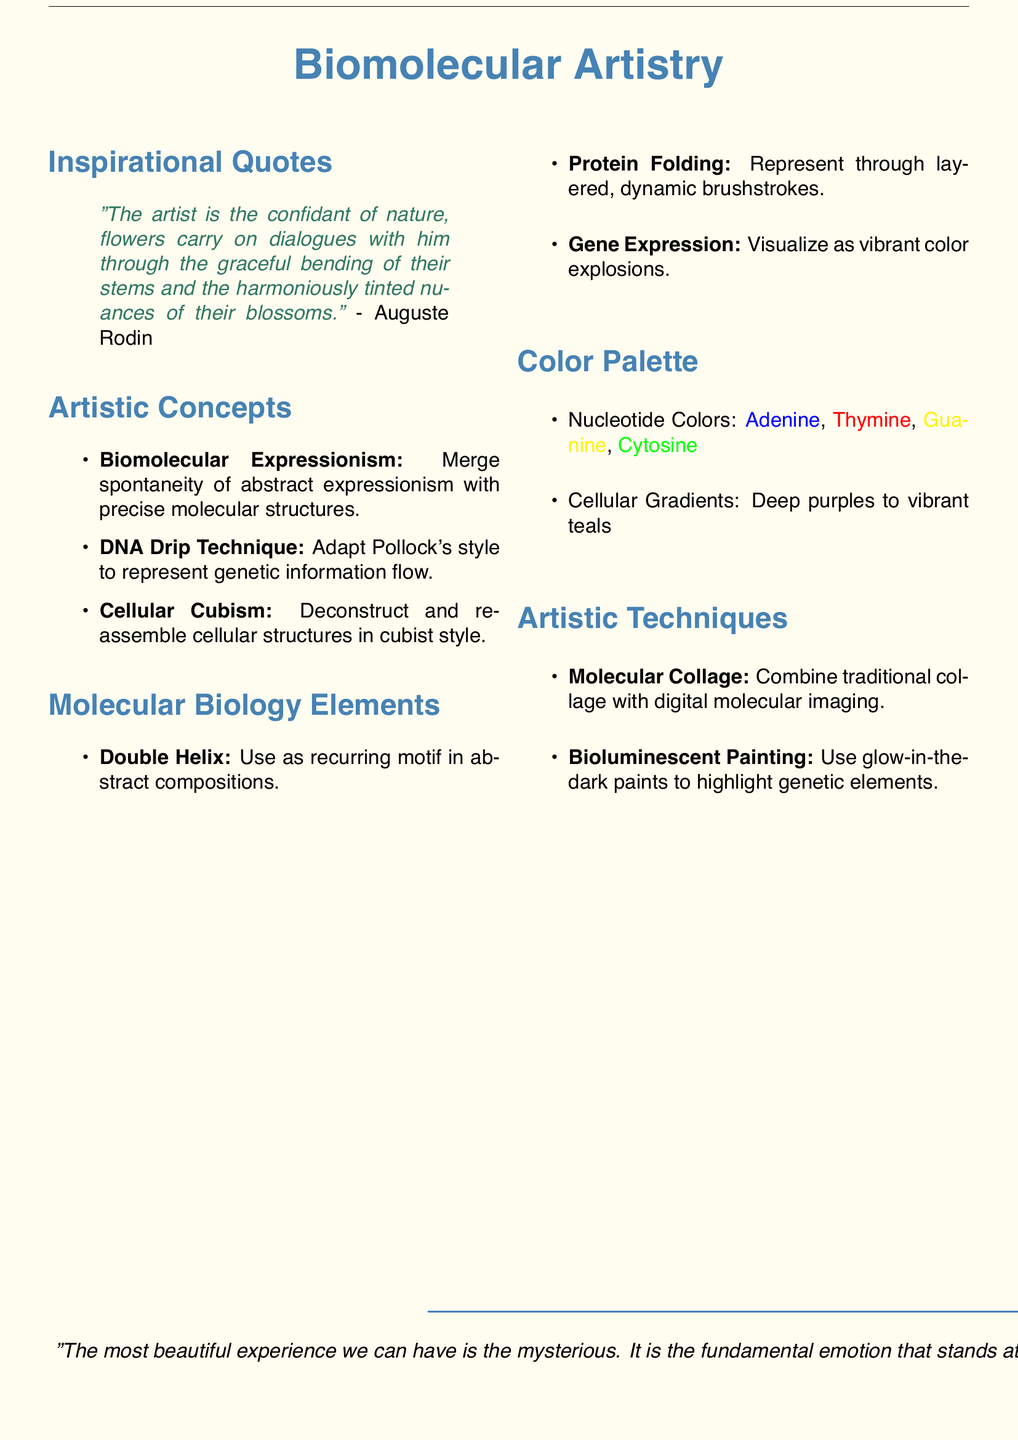What is the first quote in the document? The first quote is listed under the Inspirational Quotes section, attributed to Auguste Rodin.
Answer: "The artist is the confidant of nature, flowers carry on dialogues with him through the graceful bending of their stems and the harmoniously tinted nuances of their blossoms." What artistic concept describes the merging of abstract expressionism with molecular biology? This concept is found in the Artistic Concepts section of the document.
Answer: Biomolecular Expressionism How many elements are listed under the Molecular Biology Elements section? The number of elements is the count given in that section of the document.
Answer: Three What technique adapts Jackson Pollock's style to molecular representation? This technique is described in the Artistic Concepts section of the document.
Answer: DNA Drip Technique Which color is associated with Adenine? This information is found in the Color Palette section where nucleotide colors are specified.
Answer: #3D58A7 What artistic technique uses glow-in-the-dark paints? This is mentioned in the Artistic Techniques section of the document.
Answer: Bioluminescent Painting Which author is quoted regarding the mysterious experience? The author is referenced in the final quotation at the bottom of the document.
Answer: Albert Einstein 